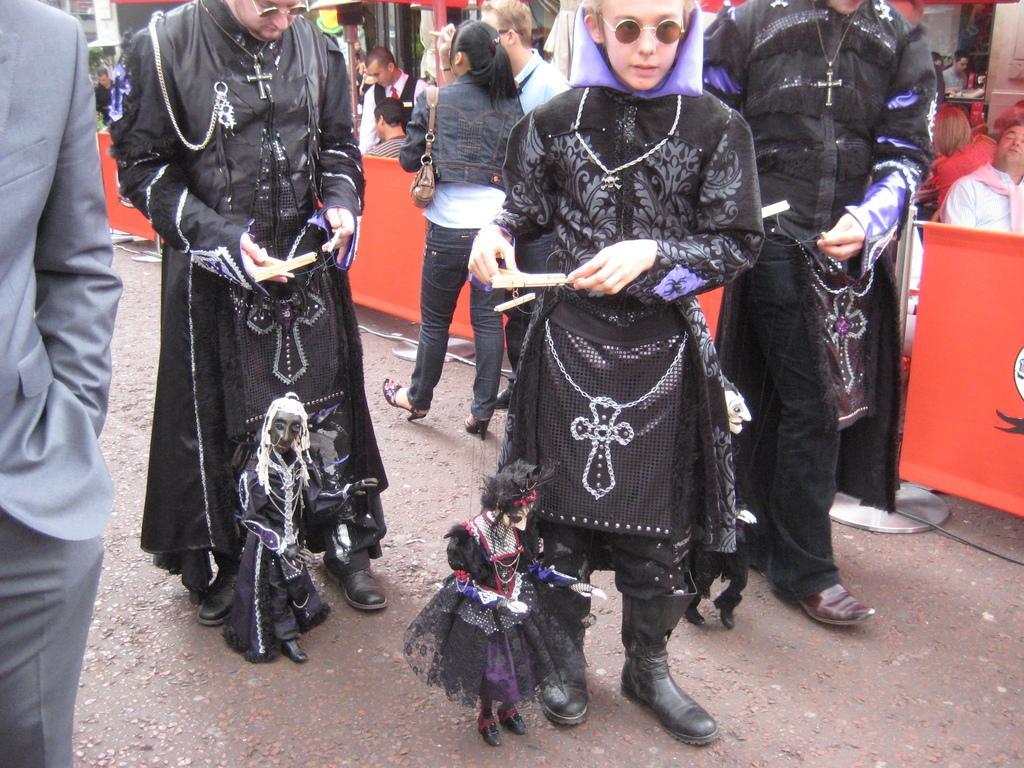In one or two sentences, can you explain what this image depicts? In this picture there are people, among the few persons holding puppets and we can see road and boards. In the background of the image we can see objects. 